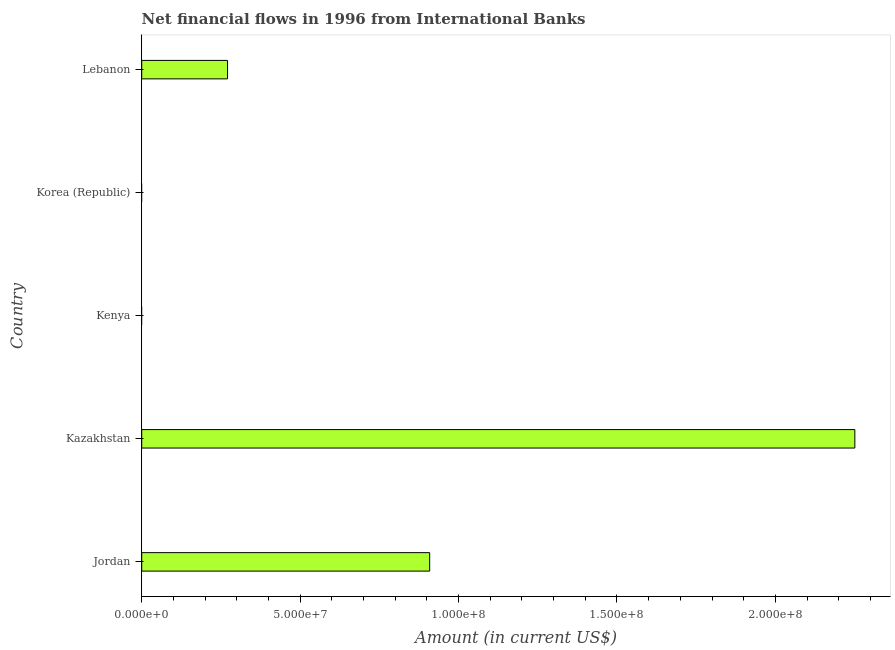What is the title of the graph?
Make the answer very short. Net financial flows in 1996 from International Banks. What is the label or title of the Y-axis?
Your response must be concise. Country. Across all countries, what is the maximum net financial flows from ibrd?
Give a very brief answer. 2.25e+08. In which country was the net financial flows from ibrd maximum?
Keep it short and to the point. Kazakhstan. What is the sum of the net financial flows from ibrd?
Your response must be concise. 3.43e+08. What is the difference between the net financial flows from ibrd in Jordan and Kazakhstan?
Keep it short and to the point. -1.34e+08. What is the average net financial flows from ibrd per country?
Offer a terse response. 6.86e+07. What is the median net financial flows from ibrd?
Your response must be concise. 2.71e+07. In how many countries, is the net financial flows from ibrd greater than 90000000 US$?
Give a very brief answer. 2. What is the ratio of the net financial flows from ibrd in Jordan to that in Lebanon?
Make the answer very short. 3.35. What is the difference between the highest and the second highest net financial flows from ibrd?
Give a very brief answer. 1.34e+08. What is the difference between the highest and the lowest net financial flows from ibrd?
Provide a short and direct response. 2.25e+08. In how many countries, is the net financial flows from ibrd greater than the average net financial flows from ibrd taken over all countries?
Give a very brief answer. 2. How many countries are there in the graph?
Provide a short and direct response. 5. What is the difference between two consecutive major ticks on the X-axis?
Give a very brief answer. 5.00e+07. Are the values on the major ticks of X-axis written in scientific E-notation?
Give a very brief answer. Yes. What is the Amount (in current US$) of Jordan?
Provide a short and direct response. 9.09e+07. What is the Amount (in current US$) of Kazakhstan?
Give a very brief answer. 2.25e+08. What is the Amount (in current US$) of Kenya?
Keep it short and to the point. 0. What is the Amount (in current US$) in Korea (Republic)?
Offer a very short reply. 0. What is the Amount (in current US$) of Lebanon?
Ensure brevity in your answer.  2.71e+07. What is the difference between the Amount (in current US$) in Jordan and Kazakhstan?
Make the answer very short. -1.34e+08. What is the difference between the Amount (in current US$) in Jordan and Lebanon?
Provide a succinct answer. 6.38e+07. What is the difference between the Amount (in current US$) in Kazakhstan and Lebanon?
Offer a very short reply. 1.98e+08. What is the ratio of the Amount (in current US$) in Jordan to that in Kazakhstan?
Provide a succinct answer. 0.4. What is the ratio of the Amount (in current US$) in Jordan to that in Lebanon?
Give a very brief answer. 3.35. What is the ratio of the Amount (in current US$) in Kazakhstan to that in Lebanon?
Give a very brief answer. 8.31. 